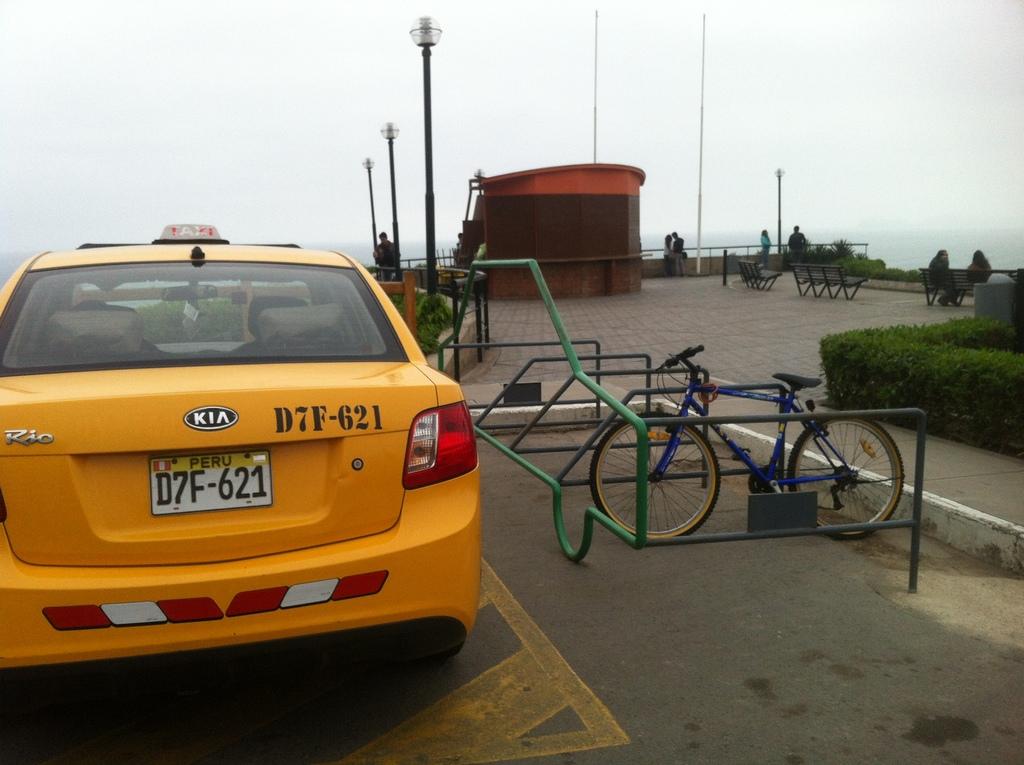What is the license plate of the taxi?
Provide a short and direct response. D7f-621. 